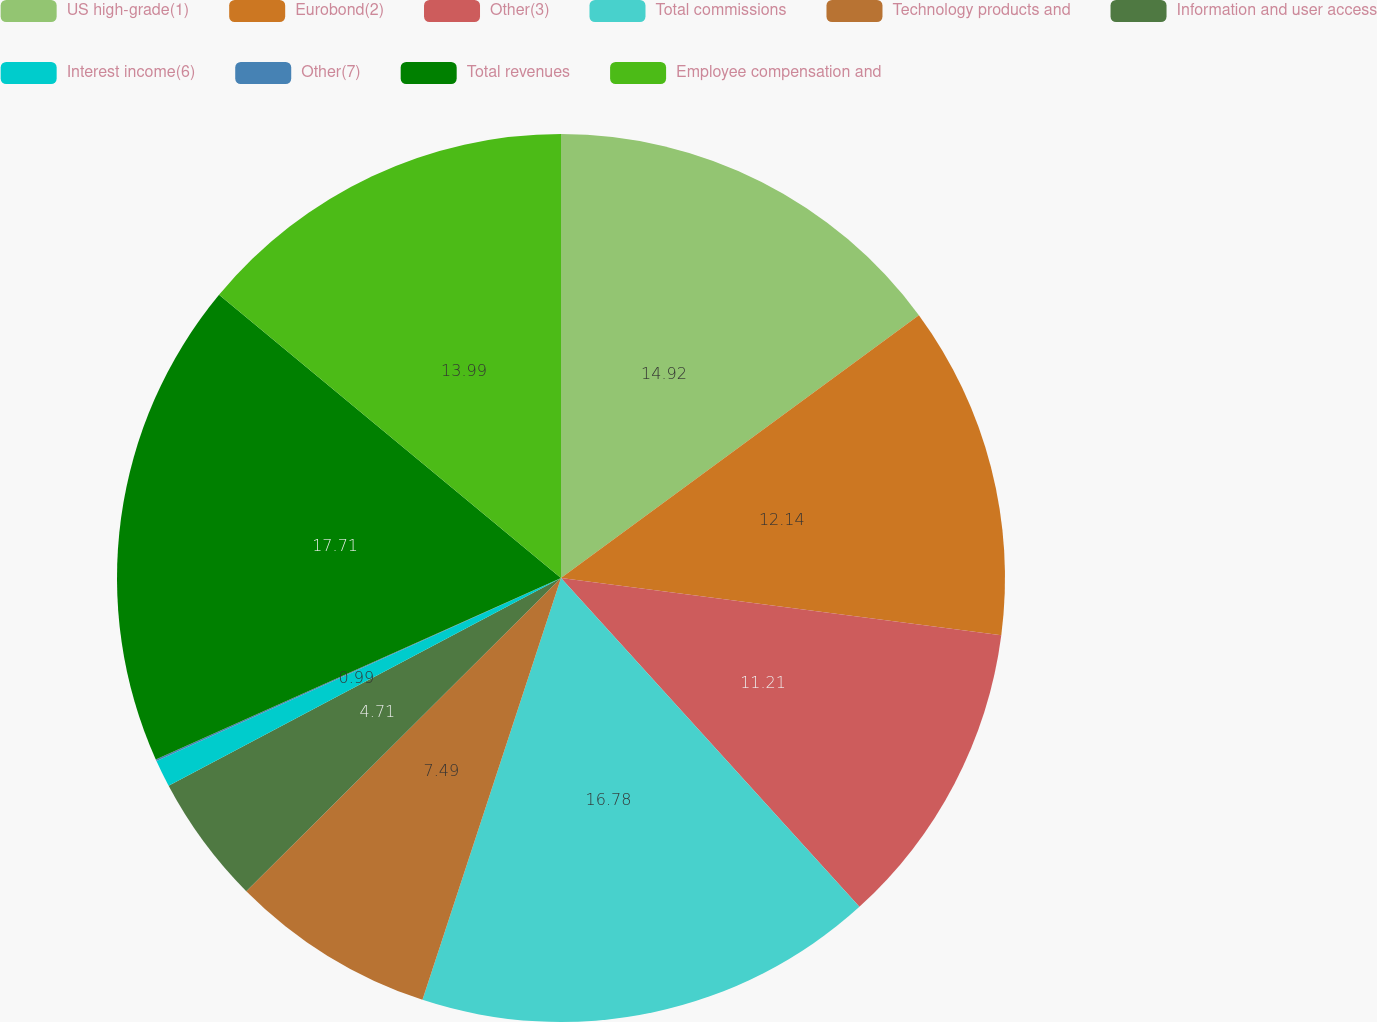Convert chart. <chart><loc_0><loc_0><loc_500><loc_500><pie_chart><fcel>US high-grade(1)<fcel>Eurobond(2)<fcel>Other(3)<fcel>Total commissions<fcel>Technology products and<fcel>Information and user access<fcel>Interest income(6)<fcel>Other(7)<fcel>Total revenues<fcel>Employee compensation and<nl><fcel>14.92%<fcel>12.14%<fcel>11.21%<fcel>16.78%<fcel>7.49%<fcel>4.71%<fcel>0.99%<fcel>0.06%<fcel>17.71%<fcel>13.99%<nl></chart> 